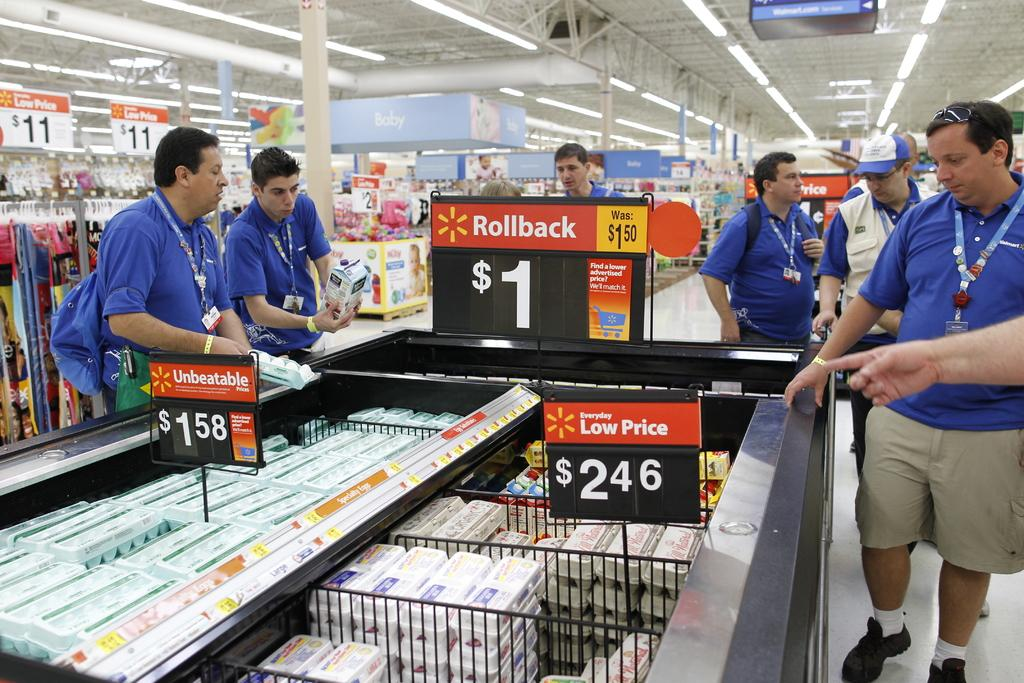Provide a one-sentence caption for the provided image. Walmart signs advertise rollbacks and products for $1. 